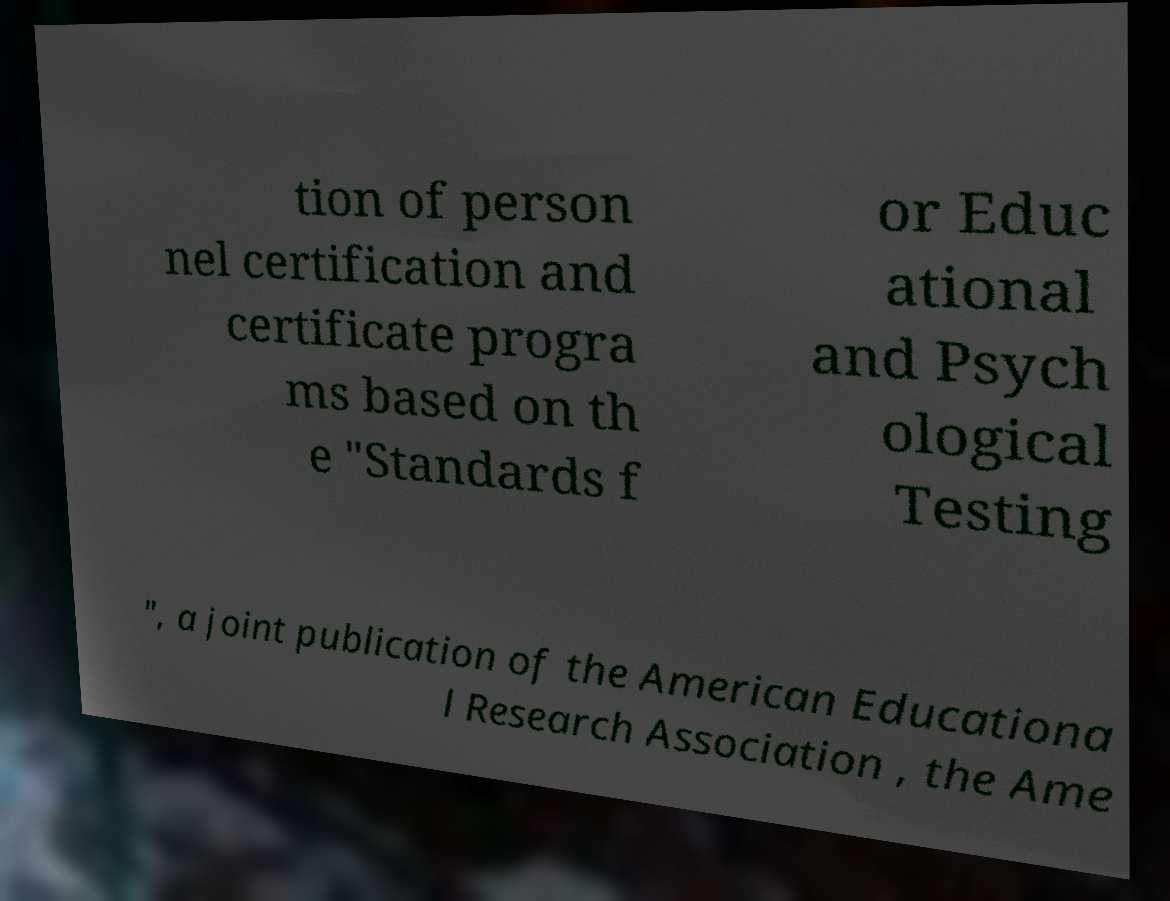Please identify and transcribe the text found in this image. tion of person nel certification and certificate progra ms based on th e "Standards f or Educ ational and Psych ological Testing ", a joint publication of the American Educationa l Research Association , the Ame 